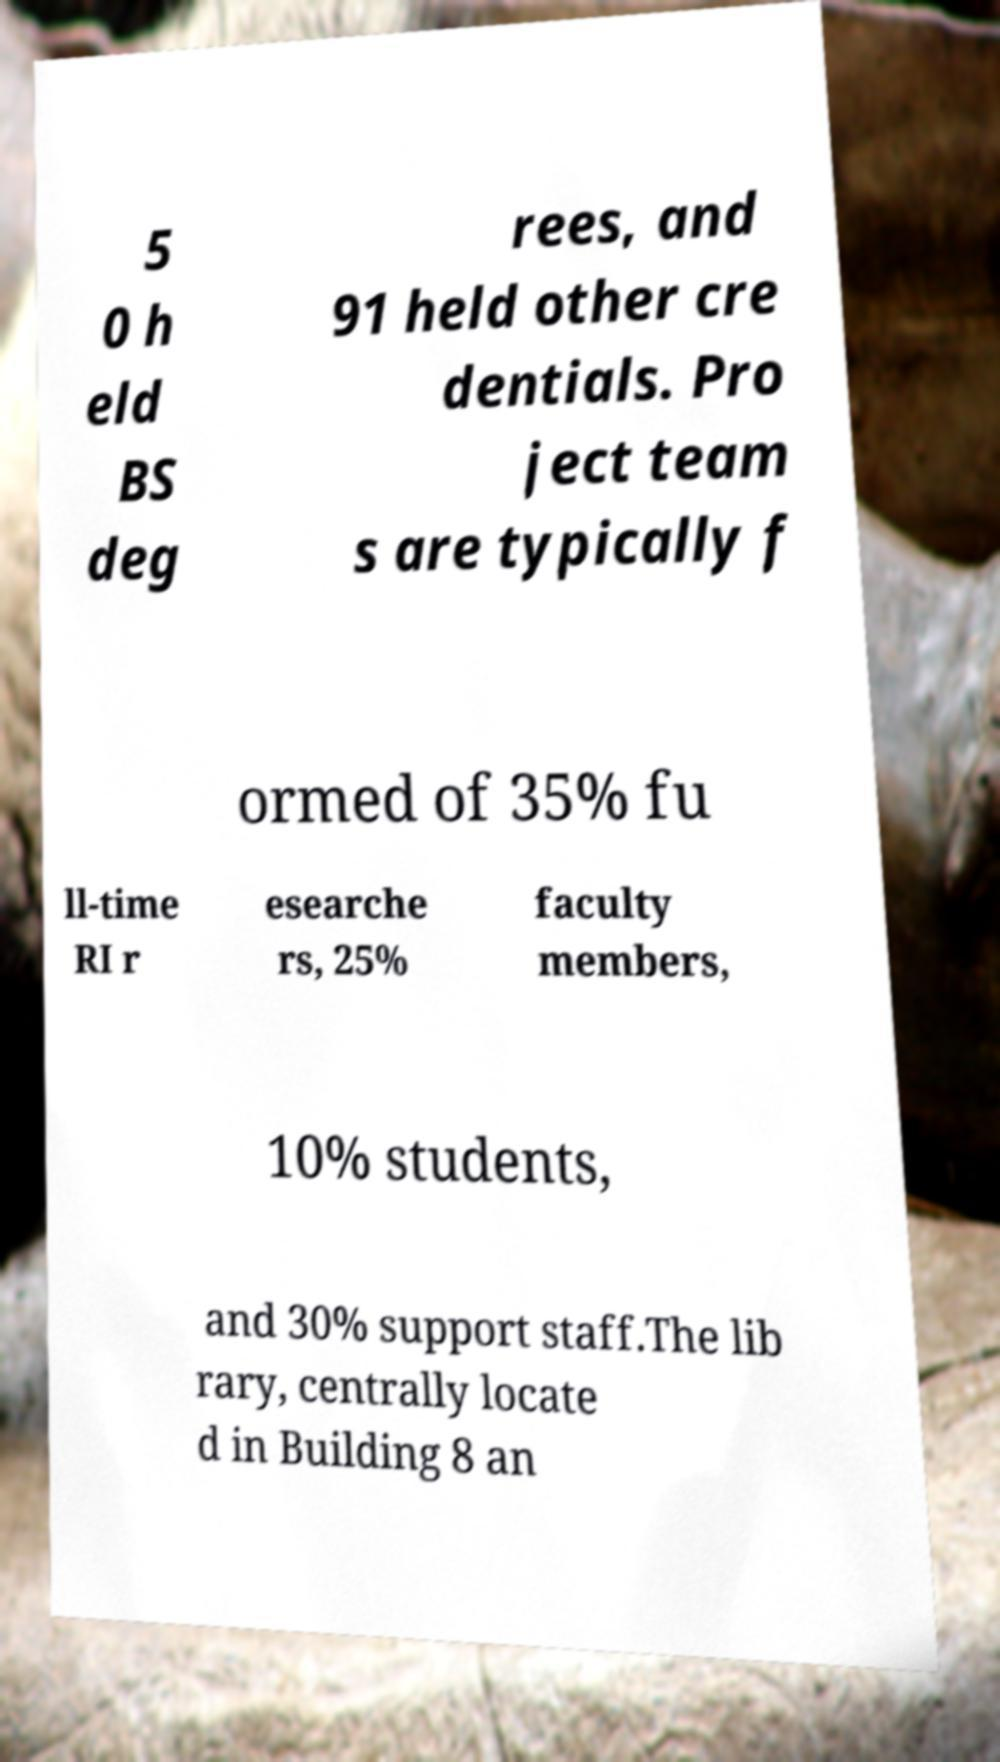Please read and relay the text visible in this image. What does it say? 5 0 h eld BS deg rees, and 91 held other cre dentials. Pro ject team s are typically f ormed of 35% fu ll-time RI r esearche rs, 25% faculty members, 10% students, and 30% support staff.The lib rary, centrally locate d in Building 8 an 